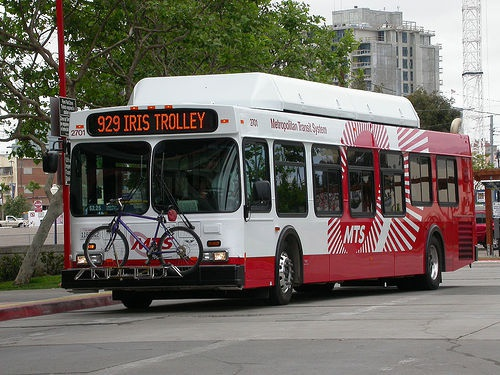Describe the objects in this image and their specific colors. I can see bus in olive, black, lightgray, darkgray, and gray tones, bicycle in olive, black, darkgray, gray, and maroon tones, car in olive, maroon, black, gray, and brown tones, and truck in olive, darkgray, gray, white, and black tones in this image. 